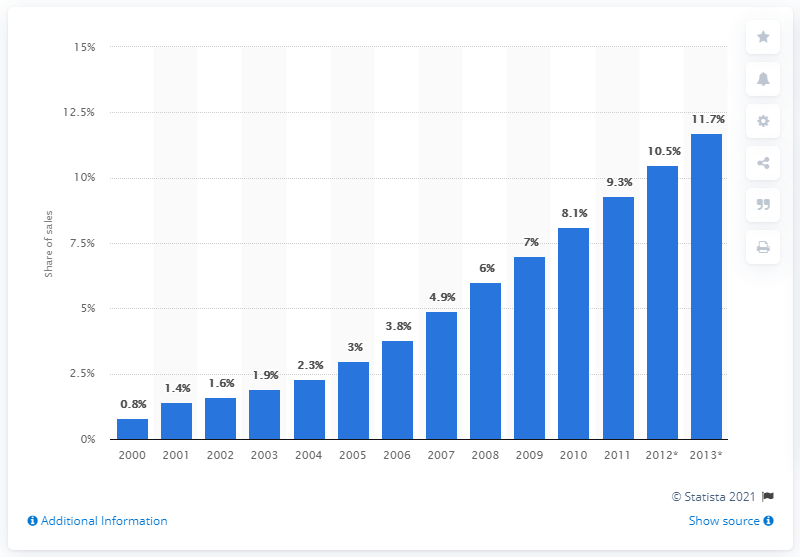Give some essential details in this illustration. In 2011, online retail accounted for 9.3% of total retail expenditure. 